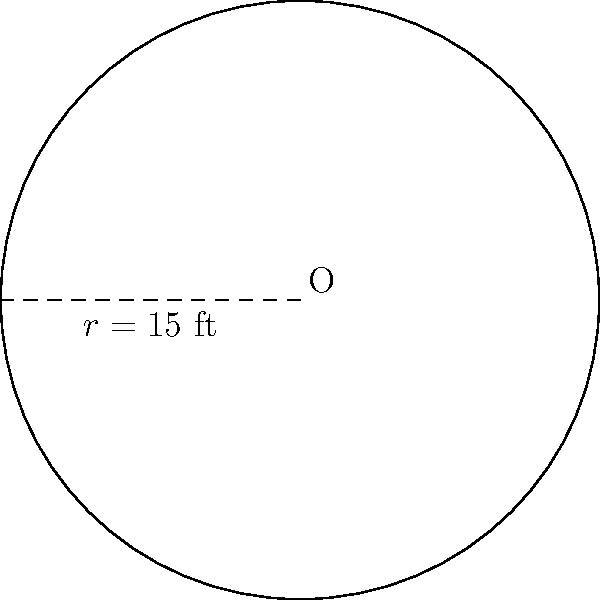As a sports journalist covering mixed martial arts, you're writing an article about the standardization of competition spaces. The UFC has decided to use circular wrestling mats for their upcoming events. If the radius of the mat is 15 feet, what is the total area of the mat? Round your answer to the nearest square foot. To find the area of a circular wrestling mat, we need to use the formula for the area of a circle:

$$A = \pi r^2$$

Where:
$A$ = area of the circle
$\pi$ = pi (approximately 3.14159)
$r$ = radius of the circle

Given:
$r = 15$ feet

Step 1: Substitute the given radius into the formula.
$$A = \pi (15)^2$$

Step 2: Calculate the square of the radius.
$$A = \pi (225)$$

Step 3: Multiply by pi.
$$A = 706.86 \text{ square feet}$$

Step 4: Round to the nearest square foot.
$$A \approx 707 \text{ square feet}$$
Answer: 707 square feet 